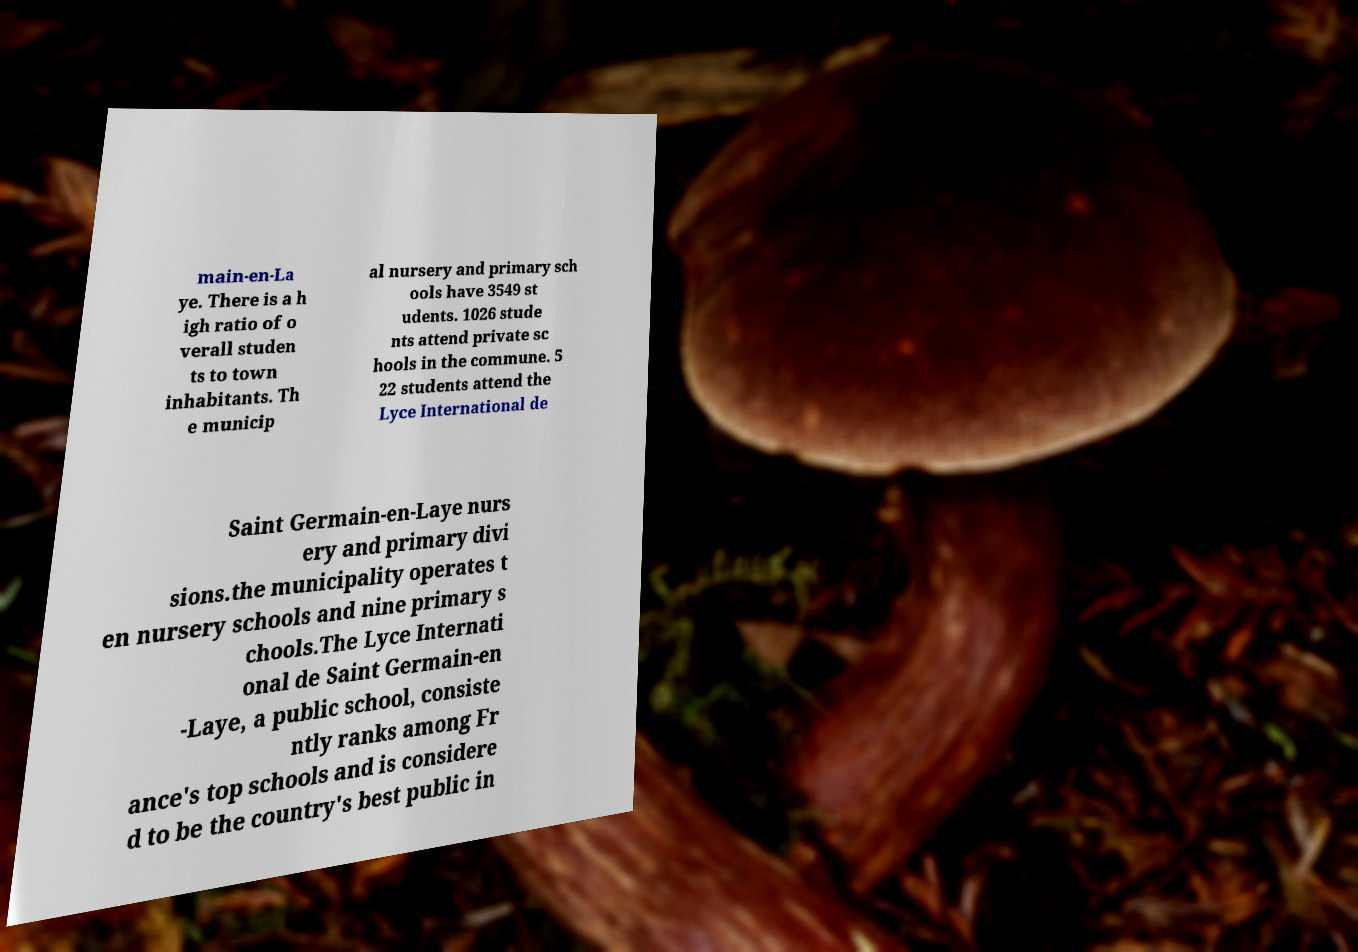Can you accurately transcribe the text from the provided image for me? main-en-La ye. There is a h igh ratio of o verall studen ts to town inhabitants. Th e municip al nursery and primary sch ools have 3549 st udents. 1026 stude nts attend private sc hools in the commune. 5 22 students attend the Lyce International de Saint Germain-en-Laye nurs ery and primary divi sions.the municipality operates t en nursery schools and nine primary s chools.The Lyce Internati onal de Saint Germain-en -Laye, a public school, consiste ntly ranks among Fr ance's top schools and is considere d to be the country's best public in 